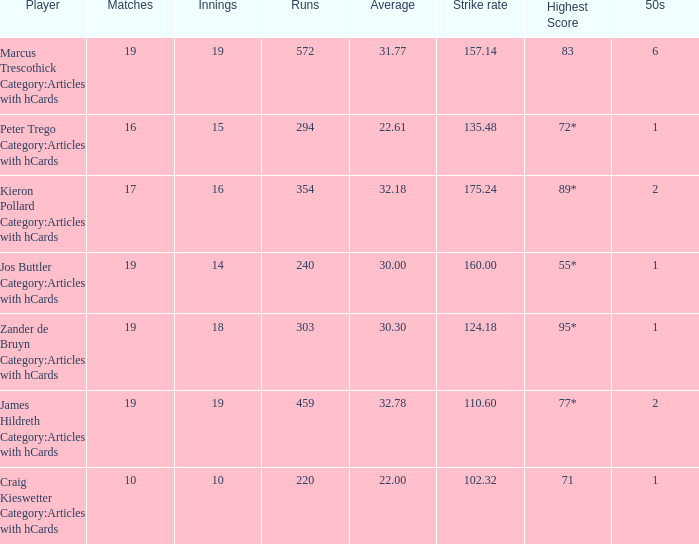How many innings has the player with a 22.61 batting average participated in? 15.0. 